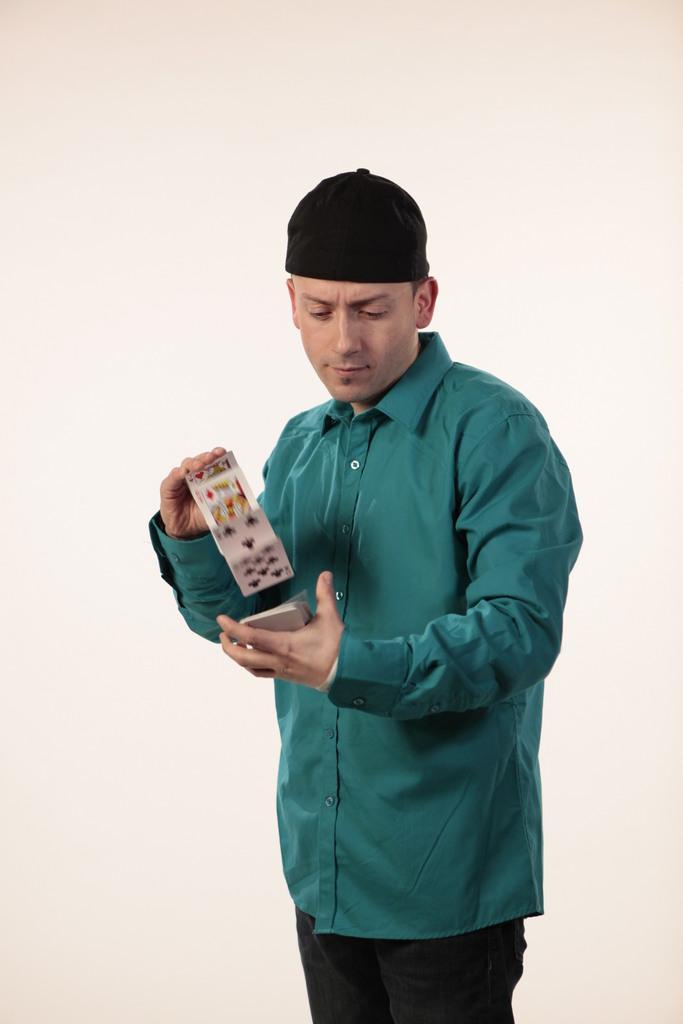Please provide a concise description of this image. A man is standing and playing with the cards, he wore a shirt, trouser and a black color cap. 